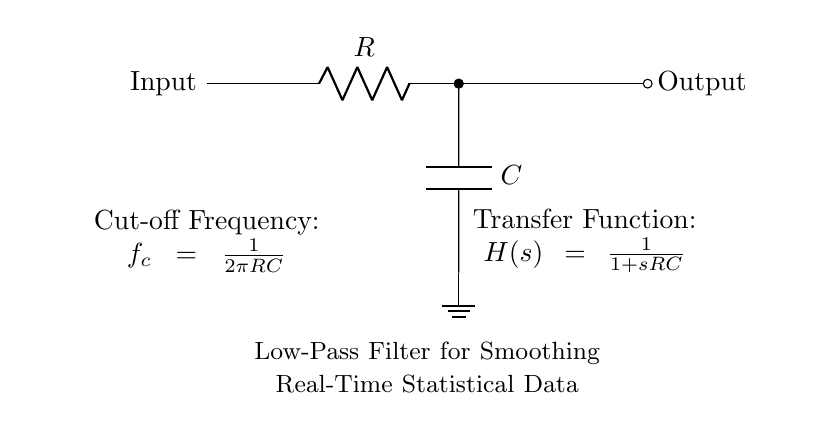What is the type of filter represented in this circuit? The circuit diagram illustrates a Low-Pass Filter, which allows signals with a frequency lower than a certain cutoff frequency to pass while attenuating higher frequencies.
Answer: Low-Pass Filter What components are used in this circuit? The components shown in the diagram are a resistor and a capacitor, which are essential for constructing the filter configuration.
Answer: Resistor, Capacitor What is the cutoff frequency formula provided in the circuit? The cutoff frequency formula is expressed as \( f_c = \frac{1}{2\pi RC} \), indicating the relationship between resistance, capacitance, and the frequency at which significant attenuation begins.
Answer: f_c = 1/(2πRC) What does the transfer function indicate about the circuit? The transfer function \( H(s) = \frac{1}{1 + sRC} \) reflects how the input signal is transformed into the output signal based on frequency, particularly in relation to the system's response.
Answer: H(s) = 1/(1 + sRC) How does the signal behave at frequencies above the cutoff frequency? At frequencies higher than the cutoff frequency, the filter significantly attenuates the signal, effectively suppressing its amplitude as it passes through the circuit.
Answer: Attenuated What is the role of the capacitor in this low-pass filter? The capacitor stores and releases energy, contributing to the time constant of the circuit, which determines how quickly the filter responds to changes in the input signal, thereby influencing the output smoothing.
Answer: Smoothing If the resistance is doubled, what happens to the cutoff frequency? Doubling the resistance will decrease the cutoff frequency, as frequency is inversely proportional to the product of resistance and capacitance, meaning the filter will allow even lower frequencies to pass.
Answer: Decreases 